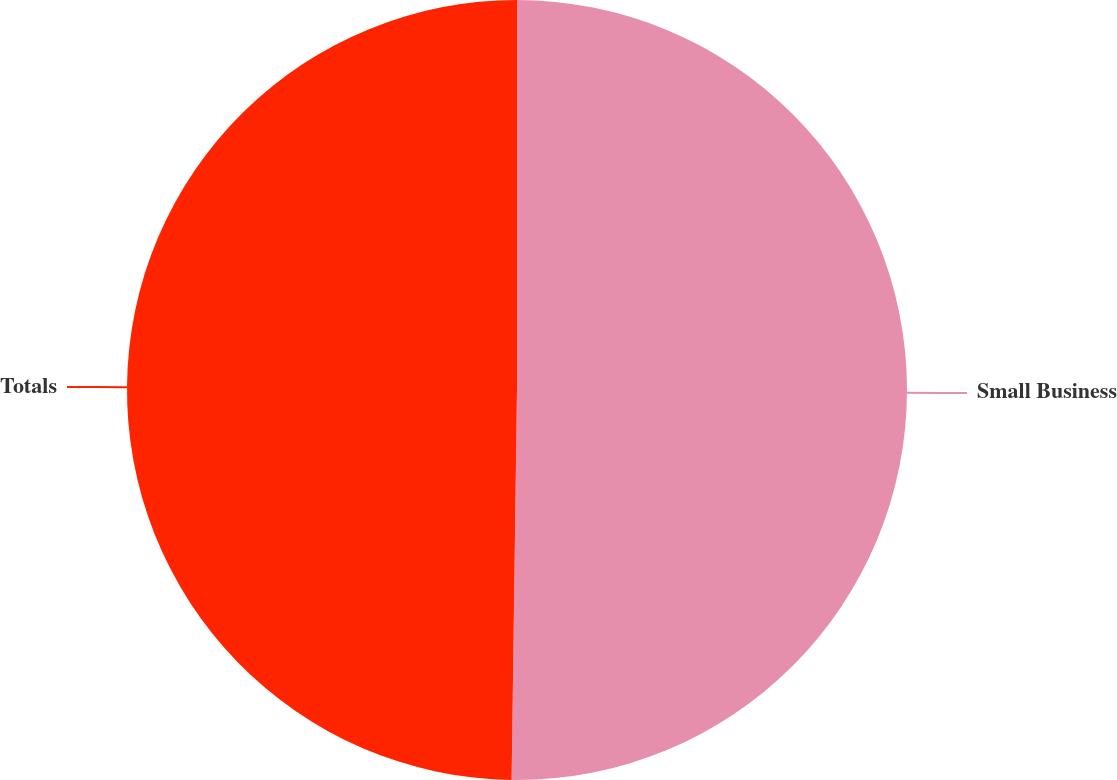Convert chart. <chart><loc_0><loc_0><loc_500><loc_500><pie_chart><fcel>Small Business<fcel>Totals<nl><fcel>50.22%<fcel>49.78%<nl></chart> 